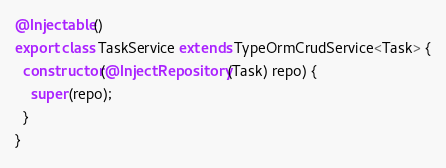<code> <loc_0><loc_0><loc_500><loc_500><_TypeScript_>@Injectable()
export class TaskService extends TypeOrmCrudService<Task> {
  constructor(@InjectRepository(Task) repo) {
    super(repo);
  }
}
</code> 